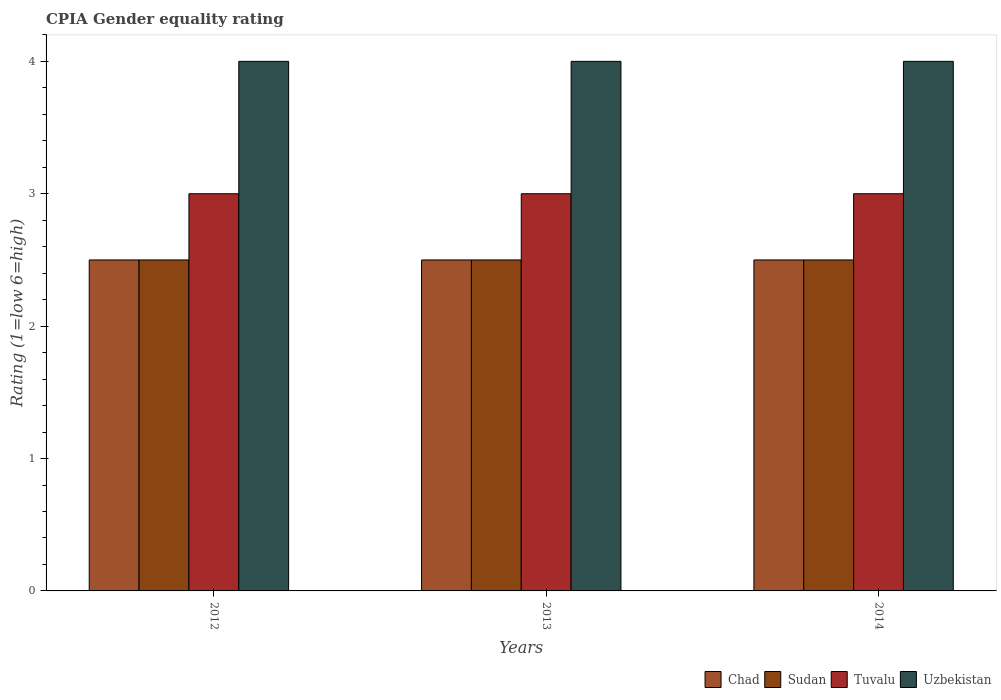How many different coloured bars are there?
Ensure brevity in your answer.  4. How many groups of bars are there?
Make the answer very short. 3. What is the label of the 3rd group of bars from the left?
Ensure brevity in your answer.  2014. In how many cases, is the number of bars for a given year not equal to the number of legend labels?
Provide a short and direct response. 0. What is the CPIA rating in Sudan in 2013?
Ensure brevity in your answer.  2.5. Across all years, what is the minimum CPIA rating in Chad?
Keep it short and to the point. 2.5. In which year was the CPIA rating in Chad maximum?
Keep it short and to the point. 2012. What is the total CPIA rating in Uzbekistan in the graph?
Your response must be concise. 12. What is the average CPIA rating in Uzbekistan per year?
Your answer should be compact. 4. In the year 2012, what is the difference between the CPIA rating in Tuvalu and CPIA rating in Sudan?
Keep it short and to the point. 0.5. In how many years, is the CPIA rating in Chad greater than 2.4?
Offer a very short reply. 3. What is the ratio of the CPIA rating in Sudan in 2013 to that in 2014?
Ensure brevity in your answer.  1. What is the difference between the highest and the second highest CPIA rating in Sudan?
Your answer should be very brief. 0. Is it the case that in every year, the sum of the CPIA rating in Uzbekistan and CPIA rating in Chad is greater than the sum of CPIA rating in Sudan and CPIA rating in Tuvalu?
Ensure brevity in your answer.  Yes. What does the 2nd bar from the left in 2014 represents?
Provide a short and direct response. Sudan. What does the 4th bar from the right in 2014 represents?
Keep it short and to the point. Chad. Are the values on the major ticks of Y-axis written in scientific E-notation?
Give a very brief answer. No. How are the legend labels stacked?
Provide a short and direct response. Horizontal. What is the title of the graph?
Provide a short and direct response. CPIA Gender equality rating. What is the Rating (1=low 6=high) of Chad in 2012?
Offer a terse response. 2.5. What is the Rating (1=low 6=high) in Sudan in 2012?
Provide a short and direct response. 2.5. What is the Rating (1=low 6=high) in Uzbekistan in 2012?
Give a very brief answer. 4. What is the Rating (1=low 6=high) of Tuvalu in 2013?
Offer a very short reply. 3. What is the Rating (1=low 6=high) of Uzbekistan in 2013?
Offer a very short reply. 4. What is the Rating (1=low 6=high) in Chad in 2014?
Your response must be concise. 2.5. What is the Rating (1=low 6=high) of Sudan in 2014?
Offer a terse response. 2.5. What is the Rating (1=low 6=high) of Uzbekistan in 2014?
Your answer should be very brief. 4. Across all years, what is the maximum Rating (1=low 6=high) of Tuvalu?
Make the answer very short. 3. Across all years, what is the minimum Rating (1=low 6=high) of Chad?
Ensure brevity in your answer.  2.5. Across all years, what is the minimum Rating (1=low 6=high) of Tuvalu?
Make the answer very short. 3. What is the total Rating (1=low 6=high) of Chad in the graph?
Offer a terse response. 7.5. What is the total Rating (1=low 6=high) in Tuvalu in the graph?
Your answer should be compact. 9. What is the total Rating (1=low 6=high) of Uzbekistan in the graph?
Make the answer very short. 12. What is the difference between the Rating (1=low 6=high) of Chad in 2012 and that in 2013?
Make the answer very short. 0. What is the difference between the Rating (1=low 6=high) in Uzbekistan in 2012 and that in 2013?
Give a very brief answer. 0. What is the difference between the Rating (1=low 6=high) of Tuvalu in 2012 and that in 2014?
Provide a succinct answer. 0. What is the difference between the Rating (1=low 6=high) of Uzbekistan in 2012 and that in 2014?
Give a very brief answer. 0. What is the difference between the Rating (1=low 6=high) of Sudan in 2013 and that in 2014?
Your answer should be compact. 0. What is the difference between the Rating (1=low 6=high) in Tuvalu in 2013 and that in 2014?
Offer a very short reply. 0. What is the difference between the Rating (1=low 6=high) of Uzbekistan in 2013 and that in 2014?
Your answer should be very brief. 0. What is the difference between the Rating (1=low 6=high) of Chad in 2012 and the Rating (1=low 6=high) of Tuvalu in 2013?
Your answer should be compact. -0.5. What is the difference between the Rating (1=low 6=high) in Chad in 2012 and the Rating (1=low 6=high) in Uzbekistan in 2013?
Offer a terse response. -1.5. What is the difference between the Rating (1=low 6=high) of Sudan in 2012 and the Rating (1=low 6=high) of Uzbekistan in 2013?
Offer a very short reply. -1.5. What is the difference between the Rating (1=low 6=high) in Chad in 2012 and the Rating (1=low 6=high) in Sudan in 2014?
Keep it short and to the point. 0. What is the difference between the Rating (1=low 6=high) in Chad in 2012 and the Rating (1=low 6=high) in Uzbekistan in 2014?
Offer a very short reply. -1.5. What is the difference between the Rating (1=low 6=high) in Tuvalu in 2012 and the Rating (1=low 6=high) in Uzbekistan in 2014?
Provide a short and direct response. -1. What is the difference between the Rating (1=low 6=high) in Chad in 2013 and the Rating (1=low 6=high) in Tuvalu in 2014?
Offer a terse response. -0.5. What is the difference between the Rating (1=low 6=high) of Sudan in 2013 and the Rating (1=low 6=high) of Tuvalu in 2014?
Give a very brief answer. -0.5. What is the average Rating (1=low 6=high) of Sudan per year?
Provide a succinct answer. 2.5. What is the average Rating (1=low 6=high) in Uzbekistan per year?
Offer a very short reply. 4. In the year 2012, what is the difference between the Rating (1=low 6=high) of Chad and Rating (1=low 6=high) of Sudan?
Ensure brevity in your answer.  0. In the year 2012, what is the difference between the Rating (1=low 6=high) in Chad and Rating (1=low 6=high) in Uzbekistan?
Offer a very short reply. -1.5. In the year 2012, what is the difference between the Rating (1=low 6=high) in Tuvalu and Rating (1=low 6=high) in Uzbekistan?
Your answer should be very brief. -1. In the year 2013, what is the difference between the Rating (1=low 6=high) in Chad and Rating (1=low 6=high) in Tuvalu?
Ensure brevity in your answer.  -0.5. In the year 2014, what is the difference between the Rating (1=low 6=high) in Chad and Rating (1=low 6=high) in Sudan?
Offer a terse response. 0. In the year 2014, what is the difference between the Rating (1=low 6=high) of Tuvalu and Rating (1=low 6=high) of Uzbekistan?
Give a very brief answer. -1. What is the ratio of the Rating (1=low 6=high) of Chad in 2012 to that in 2013?
Your response must be concise. 1. What is the ratio of the Rating (1=low 6=high) of Tuvalu in 2012 to that in 2013?
Offer a terse response. 1. What is the ratio of the Rating (1=low 6=high) in Uzbekistan in 2012 to that in 2013?
Keep it short and to the point. 1. What is the ratio of the Rating (1=low 6=high) of Chad in 2012 to that in 2014?
Provide a succinct answer. 1. What is the ratio of the Rating (1=low 6=high) in Sudan in 2012 to that in 2014?
Provide a succinct answer. 1. What is the ratio of the Rating (1=low 6=high) of Tuvalu in 2012 to that in 2014?
Make the answer very short. 1. What is the ratio of the Rating (1=low 6=high) of Uzbekistan in 2013 to that in 2014?
Your answer should be compact. 1. What is the difference between the highest and the second highest Rating (1=low 6=high) of Chad?
Your answer should be very brief. 0. What is the difference between the highest and the second highest Rating (1=low 6=high) in Sudan?
Offer a very short reply. 0. What is the difference between the highest and the lowest Rating (1=low 6=high) of Uzbekistan?
Your answer should be compact. 0. 